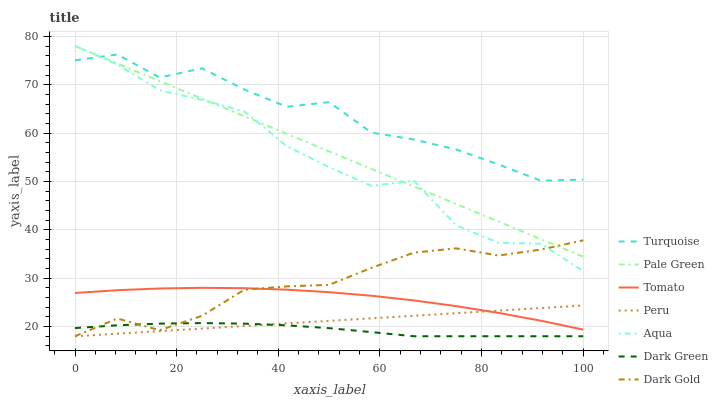Does Dark Green have the minimum area under the curve?
Answer yes or no. Yes. Does Turquoise have the maximum area under the curve?
Answer yes or no. Yes. Does Dark Gold have the minimum area under the curve?
Answer yes or no. No. Does Dark Gold have the maximum area under the curve?
Answer yes or no. No. Is Peru the smoothest?
Answer yes or no. Yes. Is Aqua the roughest?
Answer yes or no. Yes. Is Turquoise the smoothest?
Answer yes or no. No. Is Turquoise the roughest?
Answer yes or no. No. Does Dark Gold have the lowest value?
Answer yes or no. Yes. Does Turquoise have the lowest value?
Answer yes or no. No. Does Pale Green have the highest value?
Answer yes or no. Yes. Does Turquoise have the highest value?
Answer yes or no. No. Is Dark Green less than Tomato?
Answer yes or no. Yes. Is Pale Green greater than Tomato?
Answer yes or no. Yes. Does Aqua intersect Turquoise?
Answer yes or no. Yes. Is Aqua less than Turquoise?
Answer yes or no. No. Is Aqua greater than Turquoise?
Answer yes or no. No. Does Dark Green intersect Tomato?
Answer yes or no. No. 